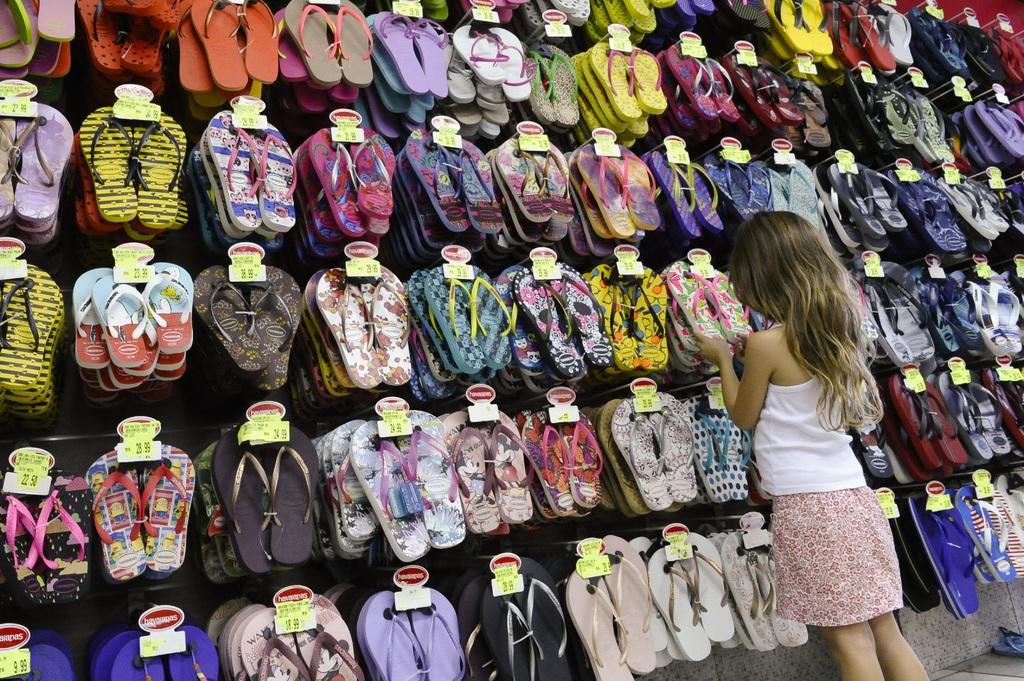What type of items can be seen in the image? There are different colors of footwear in the image. How are the footwear organized in the image? The footwear is arranged in a rack. Are there any additional details about the footwear? Price tags are present on the footwear. Is there anyone else in the image besides the footwear? Yes, there is a lady standing to the right side of the image. What type of pump can be seen in the image? There is no pump present in the image; it features footwear arranged in a rack with a lady standing nearby. 